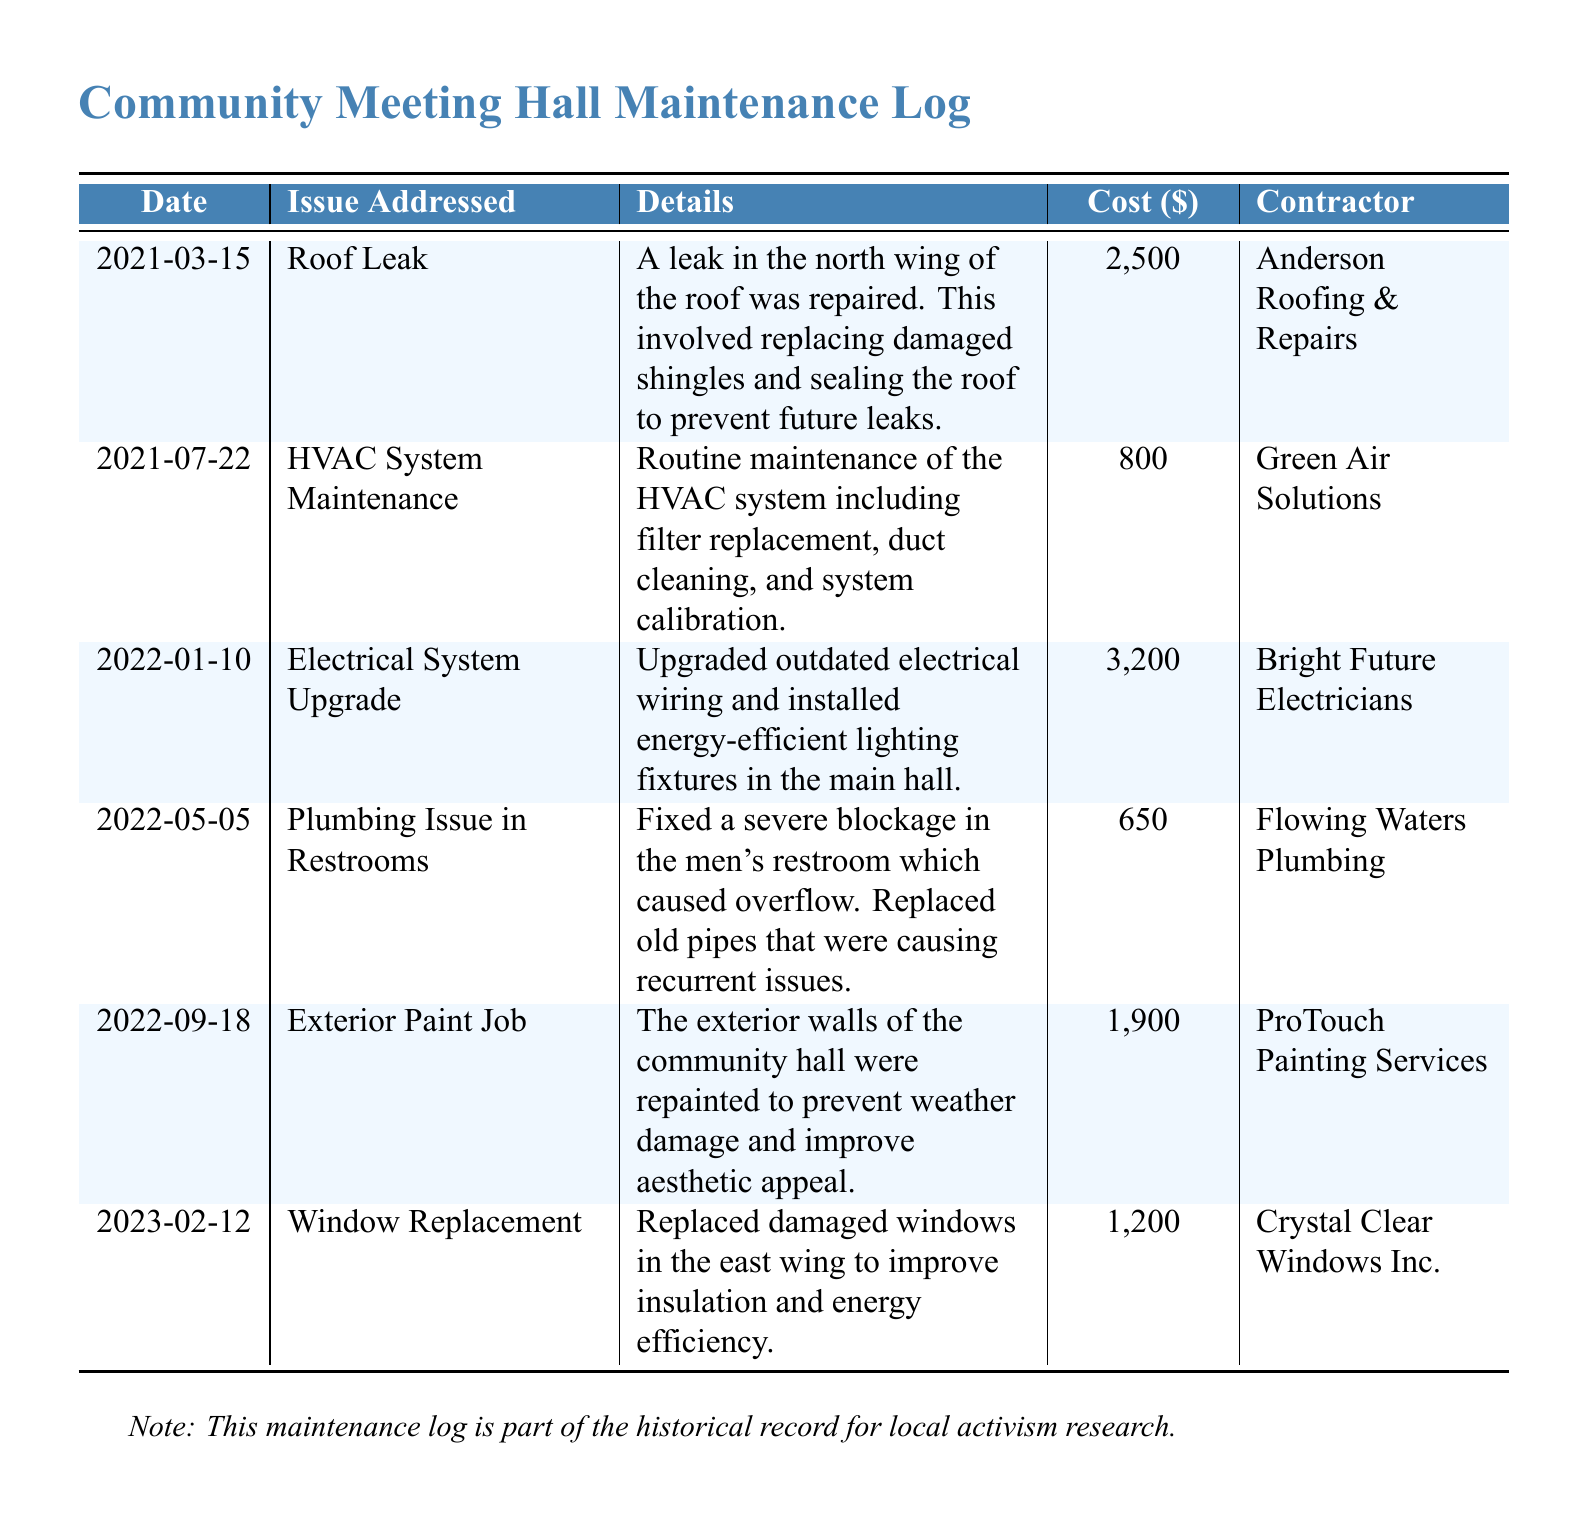What was the cost of the roof leak repair? The cost of the roof leak repair on 2021-03-15 was $2,500.
Answer: $2,500 Who performed the HVAC system maintenance? The HVAC system maintenance was performed by Green Air Solutions.
Answer: Green Air Solutions On what date was the electrical system upgraded? The electrical system was upgraded on 2022-01-10, as indicated in the log.
Answer: 2022-01-10 What issue was addressed on May 5, 2022? On May 5, 2022, a plumbing issue in the restrooms was fixed, as detailed in the log.
Answer: Plumbing Issue in Restrooms What was the total cost for the exterior paint job? The total cost for the exterior paint job was $1,900, as listed in the log.
Answer: $1,900 What contractor replaced the damaged windows in the east wing? The damaged windows in the east wing were replaced by Crystal Clear Windows Inc.
Answer: Crystal Clear Windows Inc How many maintenance issues are logged for the year 2021? There are two maintenance issues logged for the year 2021: roof leak and HVAC system maintenance.
Answer: 2 What date marks the most recent entry in the log? The most recent entry in the log is dated February 12, 2023.
Answer: 2023-02-12 Which repair had the highest cost recorded? The electrical system upgrade had the highest cost recorded at $3,200.
Answer: $3,200 